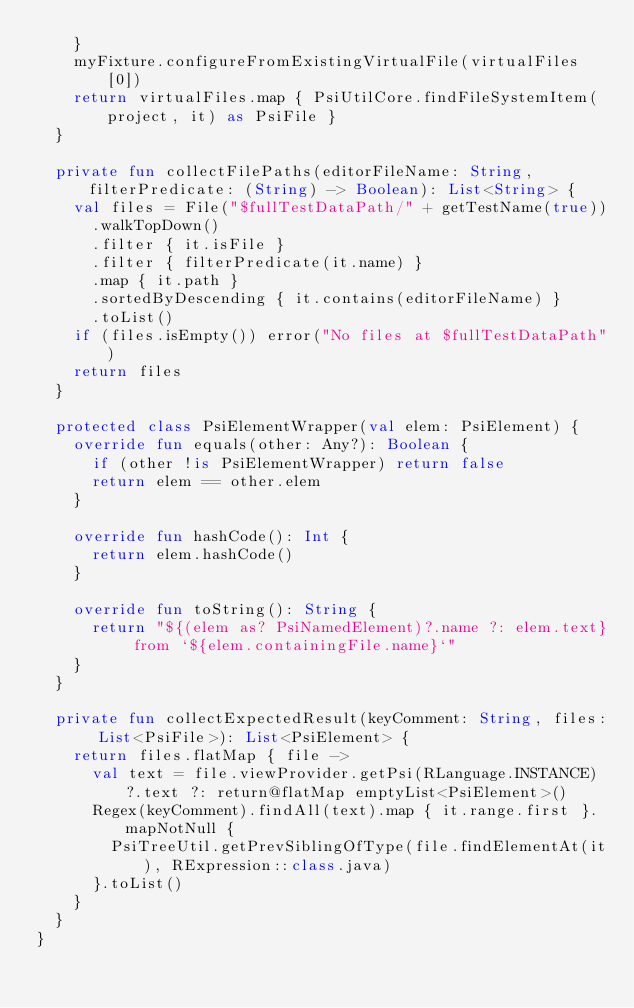<code> <loc_0><loc_0><loc_500><loc_500><_Kotlin_>    }
    myFixture.configureFromExistingVirtualFile(virtualFiles[0])
    return virtualFiles.map { PsiUtilCore.findFileSystemItem(project, it) as PsiFile }
  }

  private fun collectFilePaths(editorFileName: String, filterPredicate: (String) -> Boolean): List<String> {
    val files = File("$fullTestDataPath/" + getTestName(true))
      .walkTopDown()
      .filter { it.isFile }
      .filter { filterPredicate(it.name) }
      .map { it.path }
      .sortedByDescending { it.contains(editorFileName) }
      .toList()
    if (files.isEmpty()) error("No files at $fullTestDataPath")
    return files
  }

  protected class PsiElementWrapper(val elem: PsiElement) {
    override fun equals(other: Any?): Boolean {
      if (other !is PsiElementWrapper) return false
      return elem == other.elem
    }

    override fun hashCode(): Int {
      return elem.hashCode()
    }

    override fun toString(): String {
      return "${(elem as? PsiNamedElement)?.name ?: elem.text} from `${elem.containingFile.name}`"
    }
  }

  private fun collectExpectedResult(keyComment: String, files: List<PsiFile>): List<PsiElement> {
    return files.flatMap { file ->
      val text = file.viewProvider.getPsi(RLanguage.INSTANCE)?.text ?: return@flatMap emptyList<PsiElement>()
      Regex(keyComment).findAll(text).map { it.range.first }.mapNotNull {
        PsiTreeUtil.getPrevSiblingOfType(file.findElementAt(it), RExpression::class.java)
      }.toList()
    }
  }
}</code> 